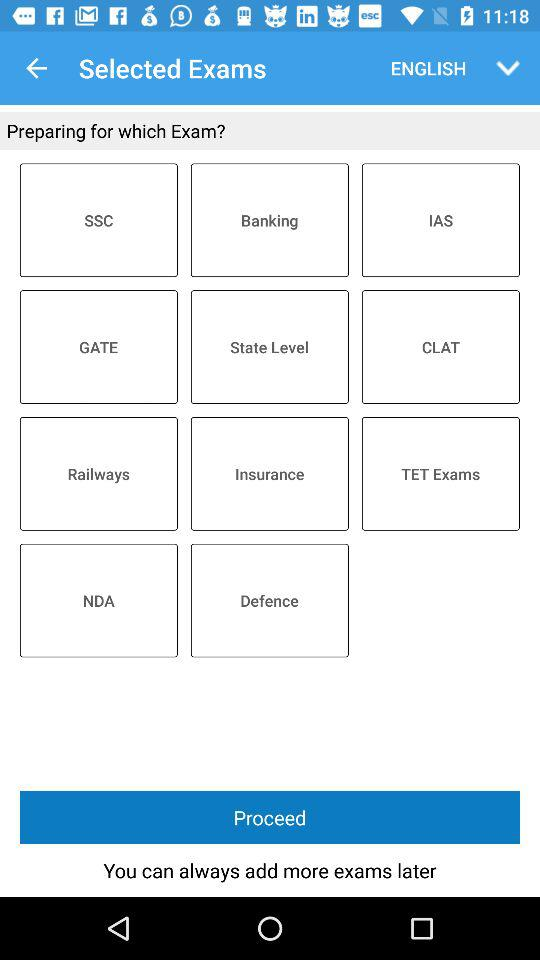Which languague is selected? The selected language is English. 